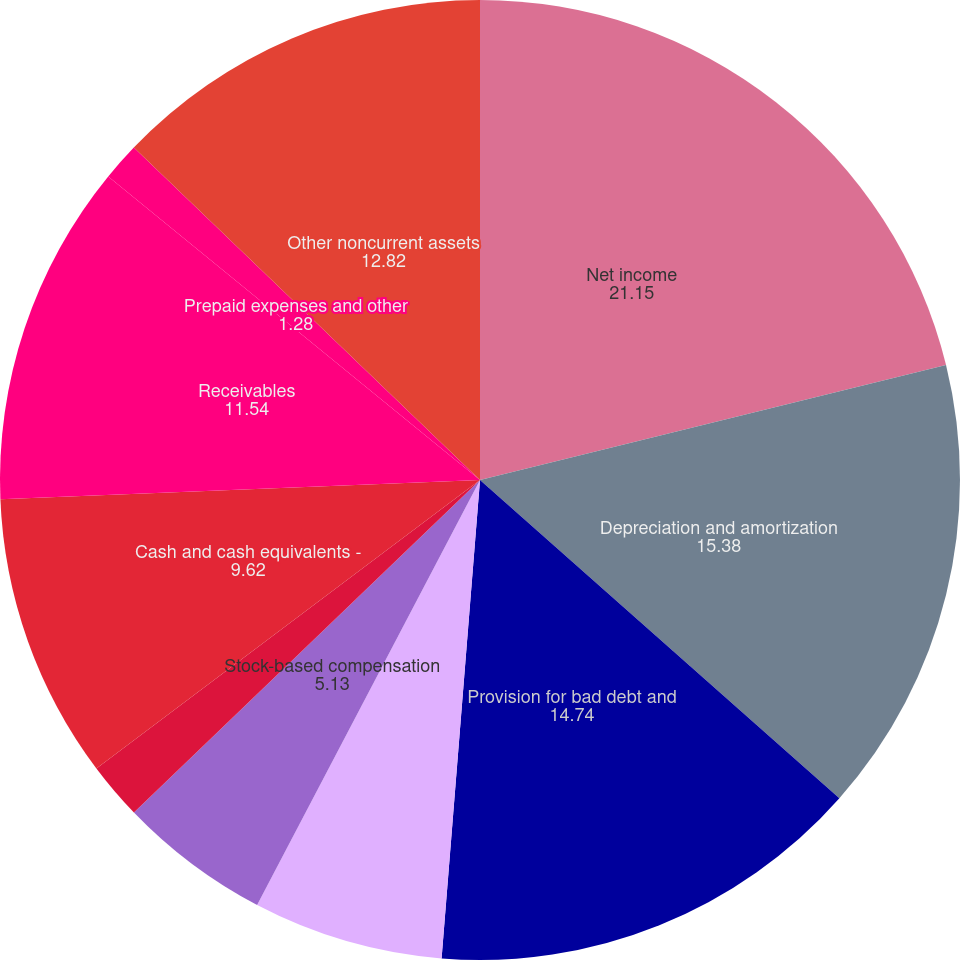<chart> <loc_0><loc_0><loc_500><loc_500><pie_chart><fcel>Net income<fcel>Depreciation and amortization<fcel>Provision for bad debt and<fcel>Provision (benefit) for<fcel>Stock-based compensation<fcel>Impairment of goodwill and<fcel>Cash and cash equivalents -<fcel>Receivables<fcel>Prepaid expenses and other<fcel>Other noncurrent assets<nl><fcel>21.15%<fcel>15.38%<fcel>14.74%<fcel>6.41%<fcel>5.13%<fcel>1.92%<fcel>9.62%<fcel>11.54%<fcel>1.28%<fcel>12.82%<nl></chart> 